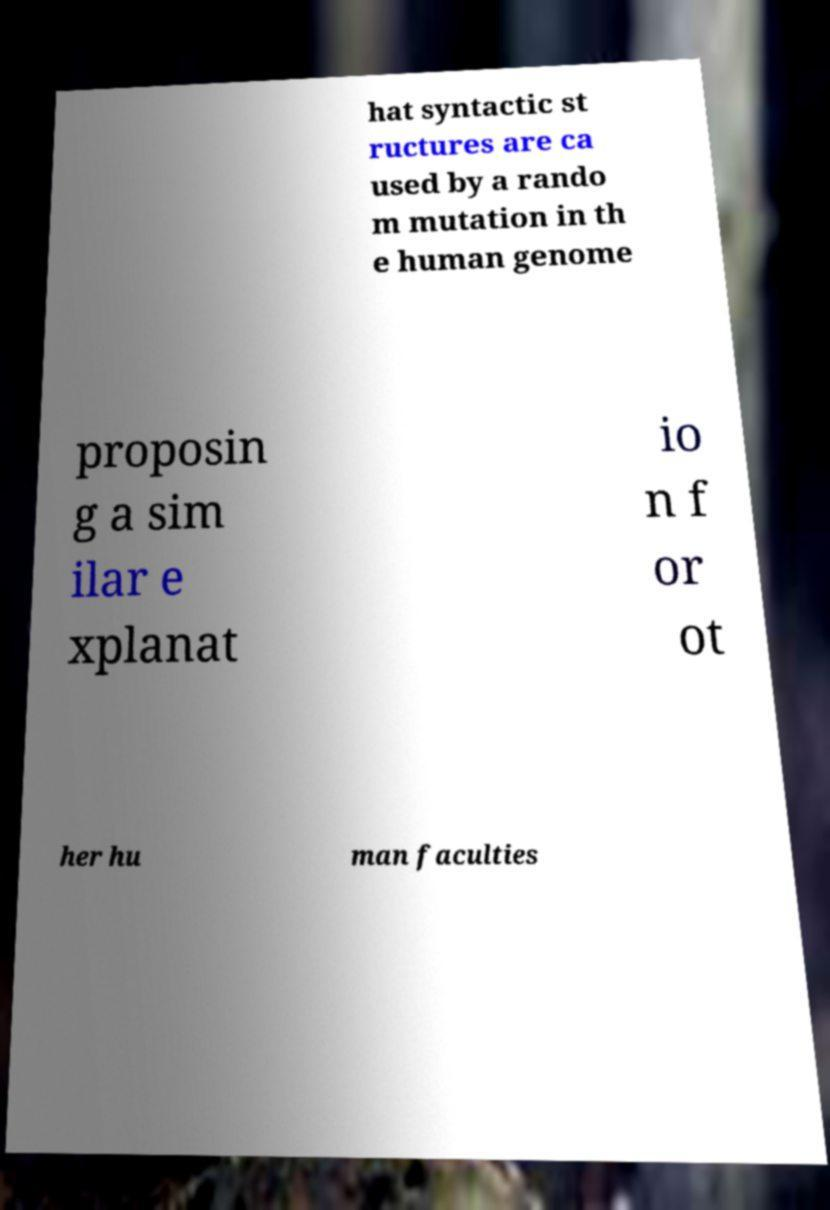Please read and relay the text visible in this image. What does it say? hat syntactic st ructures are ca used by a rando m mutation in th e human genome proposin g a sim ilar e xplanat io n f or ot her hu man faculties 